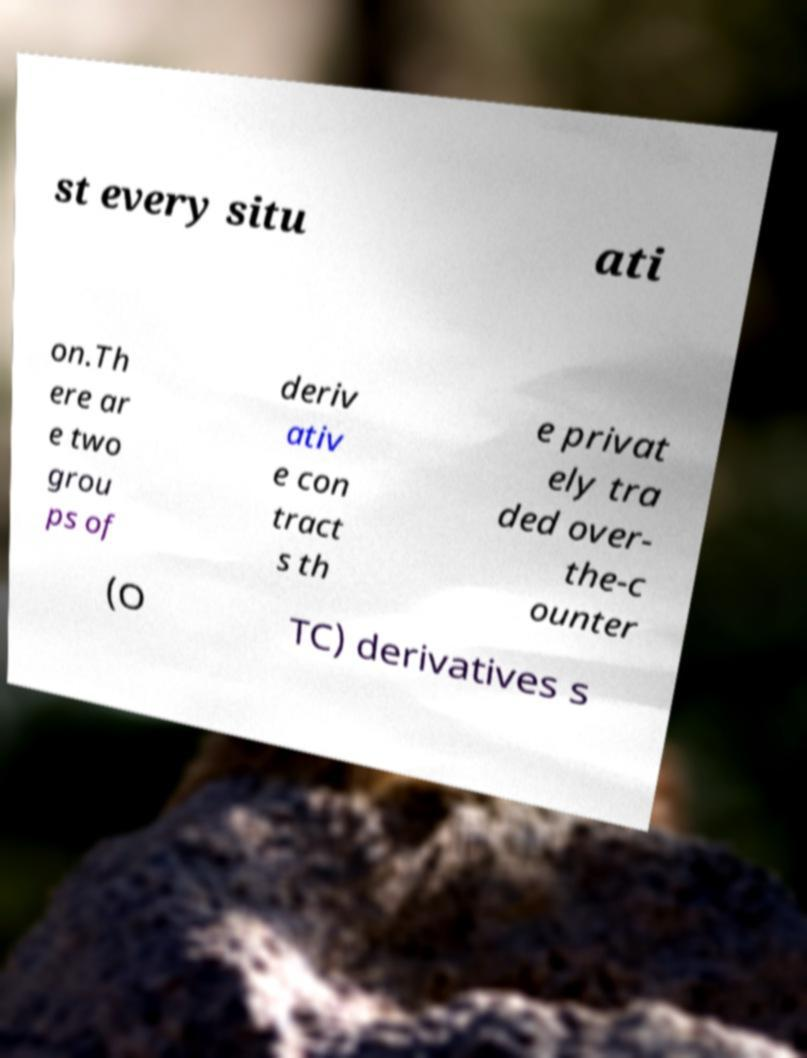Could you extract and type out the text from this image? st every situ ati on.Th ere ar e two grou ps of deriv ativ e con tract s th e privat ely tra ded over- the-c ounter (O TC) derivatives s 